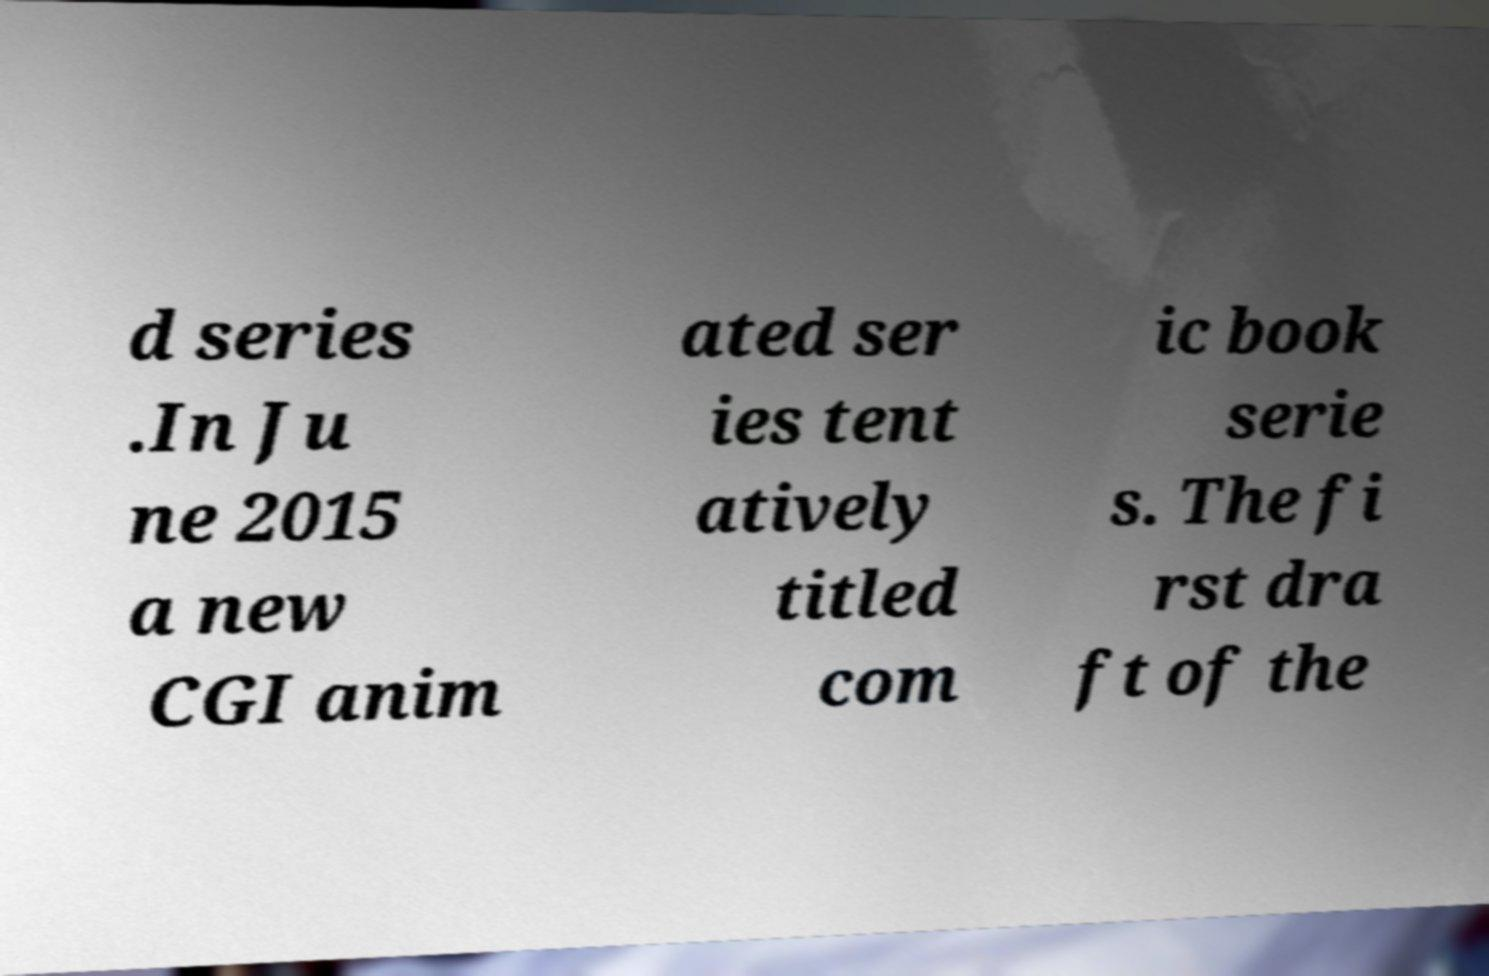Please read and relay the text visible in this image. What does it say? d series .In Ju ne 2015 a new CGI anim ated ser ies tent atively titled com ic book serie s. The fi rst dra ft of the 